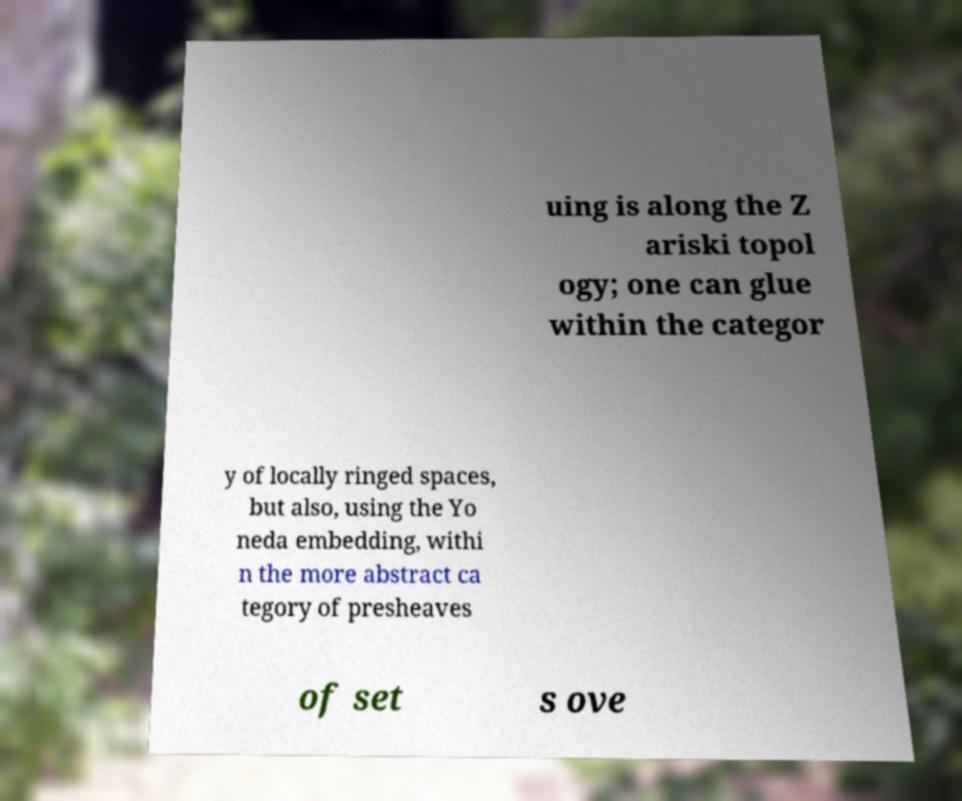Please identify and transcribe the text found in this image. uing is along the Z ariski topol ogy; one can glue within the categor y of locally ringed spaces, but also, using the Yo neda embedding, withi n the more abstract ca tegory of presheaves of set s ove 